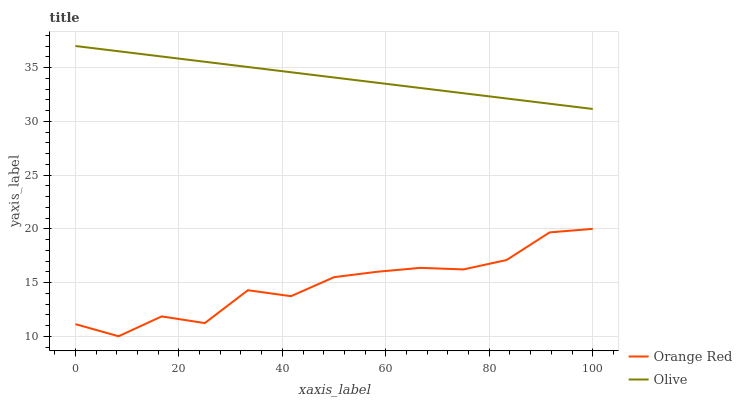Does Orange Red have the minimum area under the curve?
Answer yes or no. Yes. Does Olive have the maximum area under the curve?
Answer yes or no. Yes. Does Orange Red have the maximum area under the curve?
Answer yes or no. No. Is Olive the smoothest?
Answer yes or no. Yes. Is Orange Red the roughest?
Answer yes or no. Yes. Is Orange Red the smoothest?
Answer yes or no. No. Does Orange Red have the highest value?
Answer yes or no. No. Is Orange Red less than Olive?
Answer yes or no. Yes. Is Olive greater than Orange Red?
Answer yes or no. Yes. Does Orange Red intersect Olive?
Answer yes or no. No. 